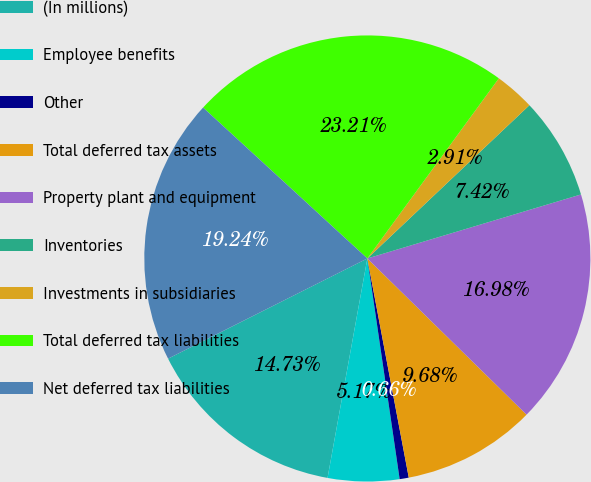<chart> <loc_0><loc_0><loc_500><loc_500><pie_chart><fcel>(In millions)<fcel>Employee benefits<fcel>Other<fcel>Total deferred tax assets<fcel>Property plant and equipment<fcel>Inventories<fcel>Investments in subsidiaries<fcel>Total deferred tax liabilities<fcel>Net deferred tax liabilities<nl><fcel>14.73%<fcel>5.17%<fcel>0.66%<fcel>9.68%<fcel>16.98%<fcel>7.42%<fcel>2.91%<fcel>23.21%<fcel>19.24%<nl></chart> 